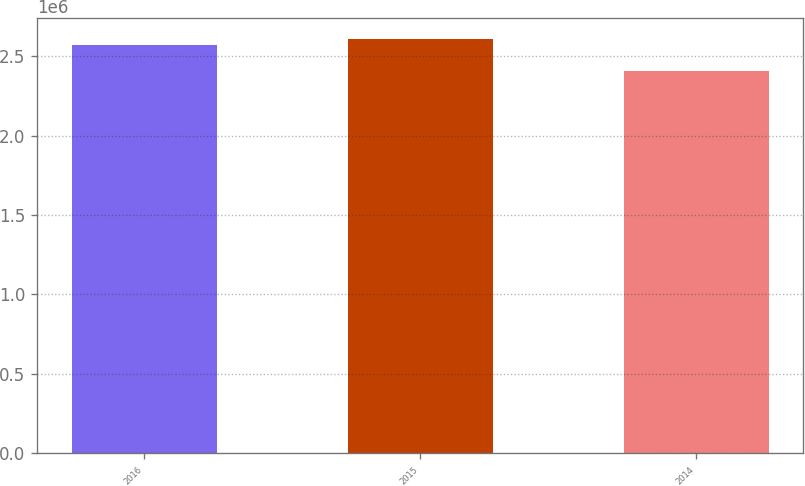<chart> <loc_0><loc_0><loc_500><loc_500><bar_chart><fcel>2016<fcel>2015<fcel>2014<nl><fcel>2.57213e+06<fcel>2.61152e+06<fcel>2.40818e+06<nl></chart> 